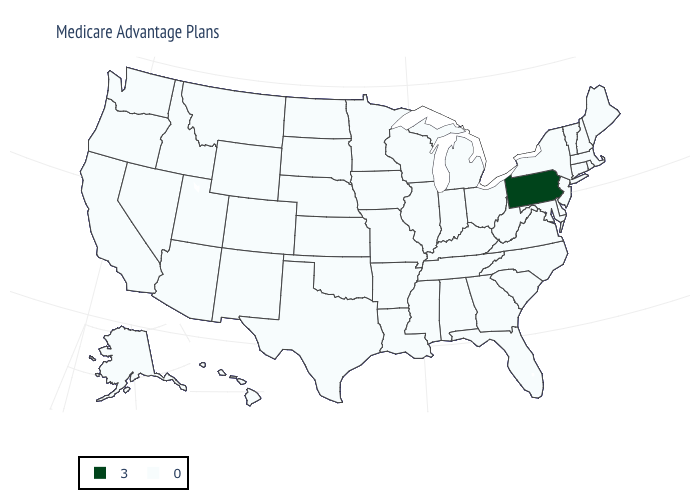Which states have the lowest value in the USA?
Be succinct. Alaska, Alabama, Arkansas, Arizona, California, Colorado, Connecticut, Delaware, Florida, Georgia, Hawaii, Iowa, Idaho, Illinois, Indiana, Kansas, Kentucky, Louisiana, Massachusetts, Maryland, Maine, Michigan, Minnesota, Missouri, Mississippi, Montana, North Carolina, North Dakota, Nebraska, New Hampshire, New Jersey, New Mexico, Nevada, New York, Ohio, Oklahoma, Oregon, Rhode Island, South Carolina, South Dakota, Tennessee, Texas, Utah, Virginia, Vermont, Washington, Wisconsin, West Virginia, Wyoming. What is the value of Idaho?
Short answer required. 0. What is the value of Nebraska?
Keep it brief. 0. What is the value of Tennessee?
Concise answer only. 0. Does North Carolina have the same value as Nevada?
Quick response, please. Yes. What is the lowest value in states that border Virginia?
Give a very brief answer. 0. Name the states that have a value in the range 3?
Keep it brief. Pennsylvania. Which states have the lowest value in the USA?
Answer briefly. Alaska, Alabama, Arkansas, Arizona, California, Colorado, Connecticut, Delaware, Florida, Georgia, Hawaii, Iowa, Idaho, Illinois, Indiana, Kansas, Kentucky, Louisiana, Massachusetts, Maryland, Maine, Michigan, Minnesota, Missouri, Mississippi, Montana, North Carolina, North Dakota, Nebraska, New Hampshire, New Jersey, New Mexico, Nevada, New York, Ohio, Oklahoma, Oregon, Rhode Island, South Carolina, South Dakota, Tennessee, Texas, Utah, Virginia, Vermont, Washington, Wisconsin, West Virginia, Wyoming. What is the value of Michigan?
Write a very short answer. 0. Name the states that have a value in the range 0?
Short answer required. Alaska, Alabama, Arkansas, Arizona, California, Colorado, Connecticut, Delaware, Florida, Georgia, Hawaii, Iowa, Idaho, Illinois, Indiana, Kansas, Kentucky, Louisiana, Massachusetts, Maryland, Maine, Michigan, Minnesota, Missouri, Mississippi, Montana, North Carolina, North Dakota, Nebraska, New Hampshire, New Jersey, New Mexico, Nevada, New York, Ohio, Oklahoma, Oregon, Rhode Island, South Carolina, South Dakota, Tennessee, Texas, Utah, Virginia, Vermont, Washington, Wisconsin, West Virginia, Wyoming. Name the states that have a value in the range 3?
Quick response, please. Pennsylvania. What is the value of Rhode Island?
Concise answer only. 0. Name the states that have a value in the range 3?
Short answer required. Pennsylvania. What is the highest value in the West ?
Answer briefly. 0. What is the value of Wyoming?
Write a very short answer. 0. 